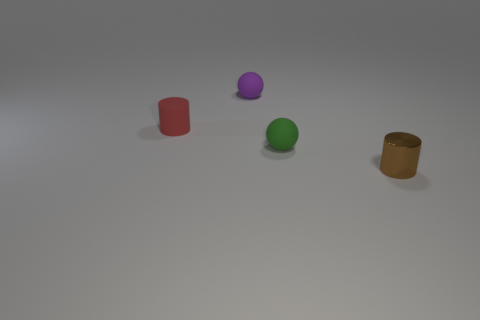How would you describe the texture of the surface on which the objects are placed? The surface appears to be a smooth, matte texture, lacking any significant gloss or reflection. It seems like a flat, even material, which could be a synthetic setup for rendering the objects in a controlled lighting environment.  Are the objects casting shadows, and what does that indicate about the light source? Yes, each object is casting a shadow, which indicates that there is a directional light source present in the scene. The soft edges of the shadows suggest that the light is not extremely close to the objects or overly intense, creating a more diffused light effect. 